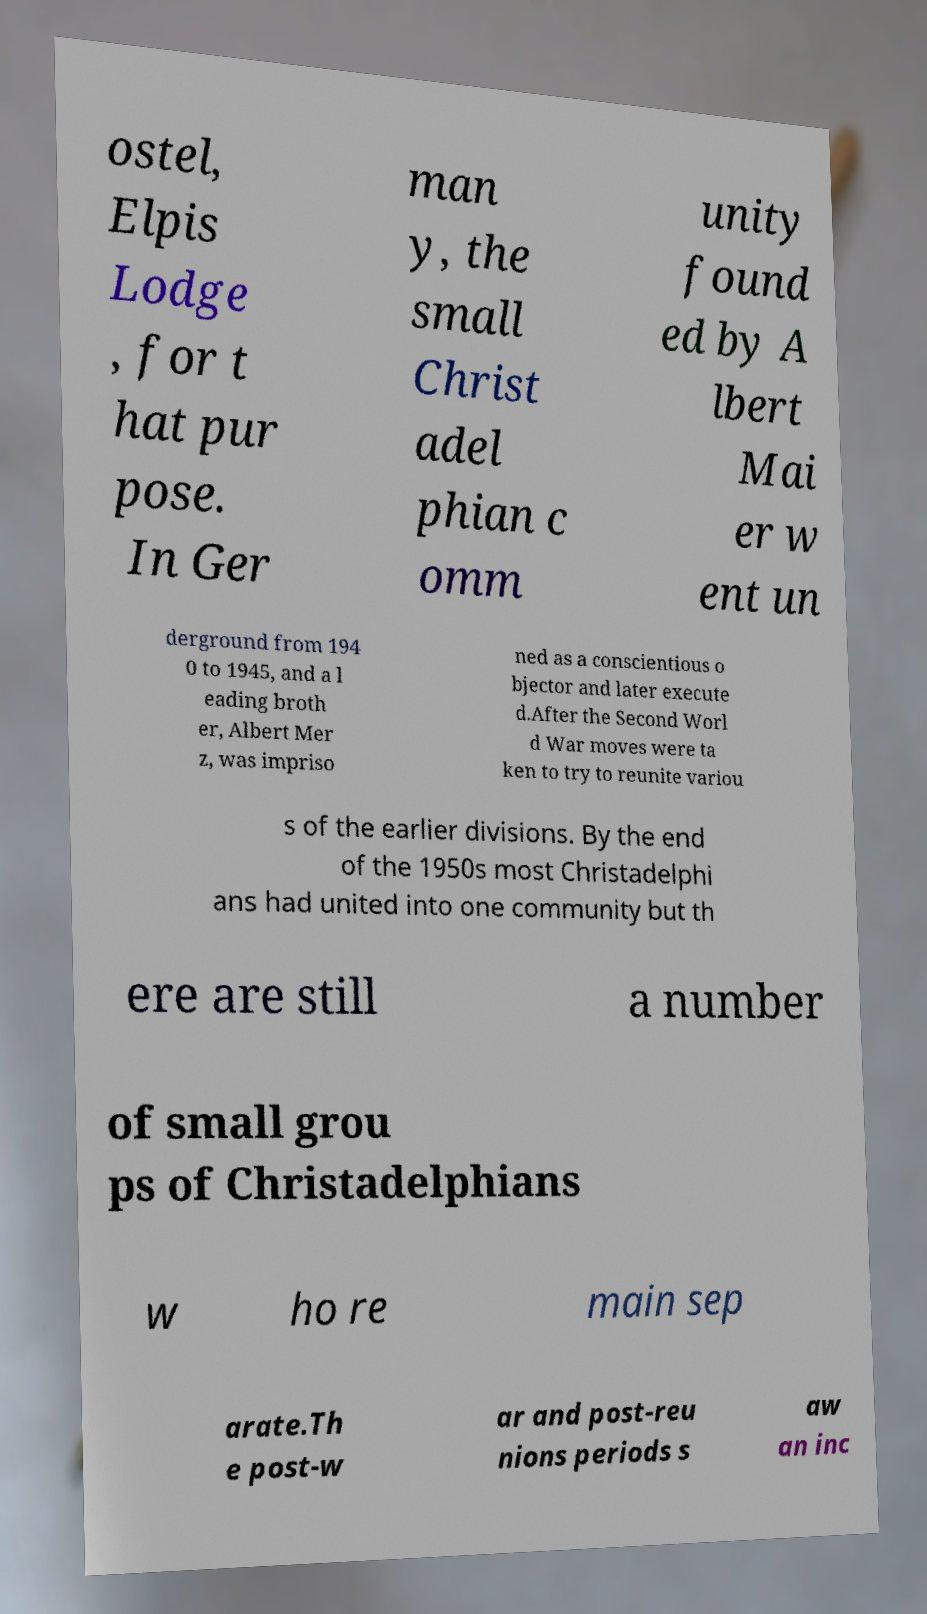What messages or text are displayed in this image? I need them in a readable, typed format. ostel, Elpis Lodge , for t hat pur pose. In Ger man y, the small Christ adel phian c omm unity found ed by A lbert Mai er w ent un derground from 194 0 to 1945, and a l eading broth er, Albert Mer z, was impriso ned as a conscientious o bjector and later execute d.After the Second Worl d War moves were ta ken to try to reunite variou s of the earlier divisions. By the end of the 1950s most Christadelphi ans had united into one community but th ere are still a number of small grou ps of Christadelphians w ho re main sep arate.Th e post-w ar and post-reu nions periods s aw an inc 